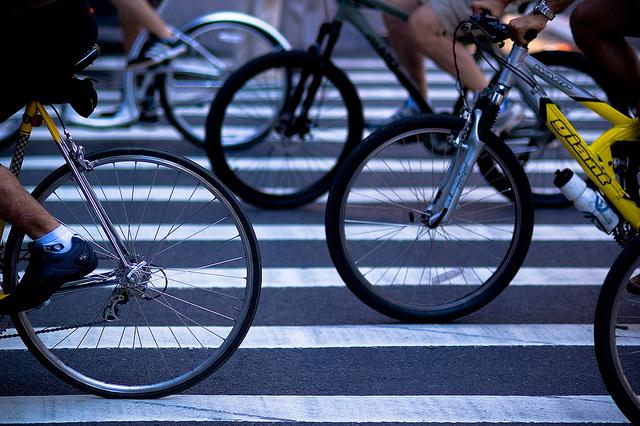Is this a bike race?
Concise answer only. Yes. How many wheels are there?
Quick response, please. 5. Is this bicycle in use?
Short answer required. Yes. What color is the bike on the right?
Write a very short answer. Yellow. 